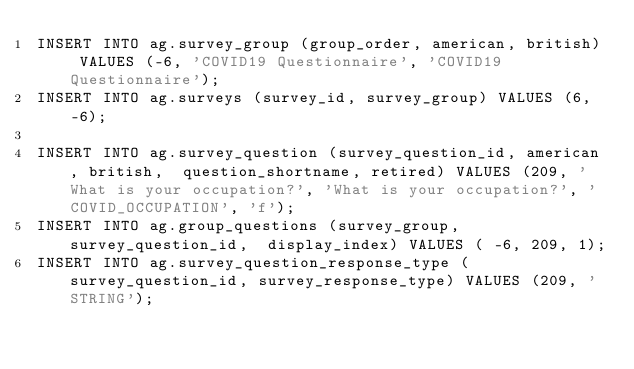<code> <loc_0><loc_0><loc_500><loc_500><_SQL_>INSERT INTO ag.survey_group (group_order, american, british) VALUES (-6, 'COVID19 Questionnaire', 'COVID19 Questionnaire');
INSERT INTO ag.surveys (survey_id, survey_group) VALUES (6, -6);

INSERT INTO ag.survey_question (survey_question_id, american, british,  question_shortname, retired) VALUES (209, 'What is your occupation?', 'What is your occupation?', 'COVID_OCCUPATION', 'f');
INSERT INTO ag.group_questions (survey_group, survey_question_id,  display_index) VALUES ( -6, 209, 1);
INSERT INTO ag.survey_question_response_type (survey_question_id, survey_response_type) VALUES (209, 'STRING');
</code> 